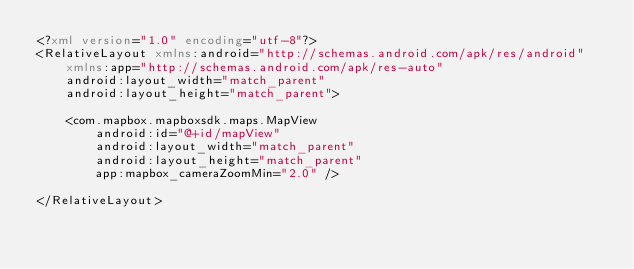Convert code to text. <code><loc_0><loc_0><loc_500><loc_500><_XML_><?xml version="1.0" encoding="utf-8"?>
<RelativeLayout xmlns:android="http://schemas.android.com/apk/res/android"
    xmlns:app="http://schemas.android.com/apk/res-auto"
    android:layout_width="match_parent"
    android:layout_height="match_parent">

    <com.mapbox.mapboxsdk.maps.MapView
        android:id="@+id/mapView"
        android:layout_width="match_parent"
        android:layout_height="match_parent"
        app:mapbox_cameraZoomMin="2.0" />

</RelativeLayout></code> 